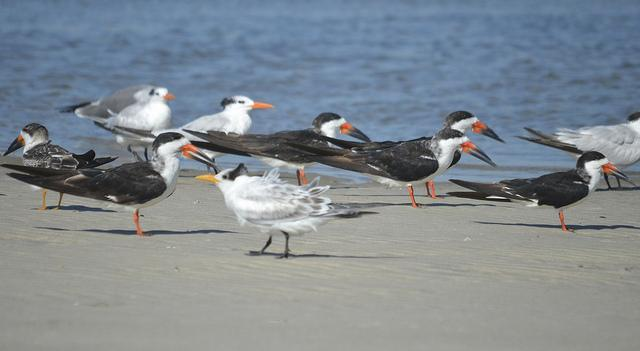What part does this animal have that is absent in humans? Please explain your reasoning. wings. Humans normally have arms and not wings. 